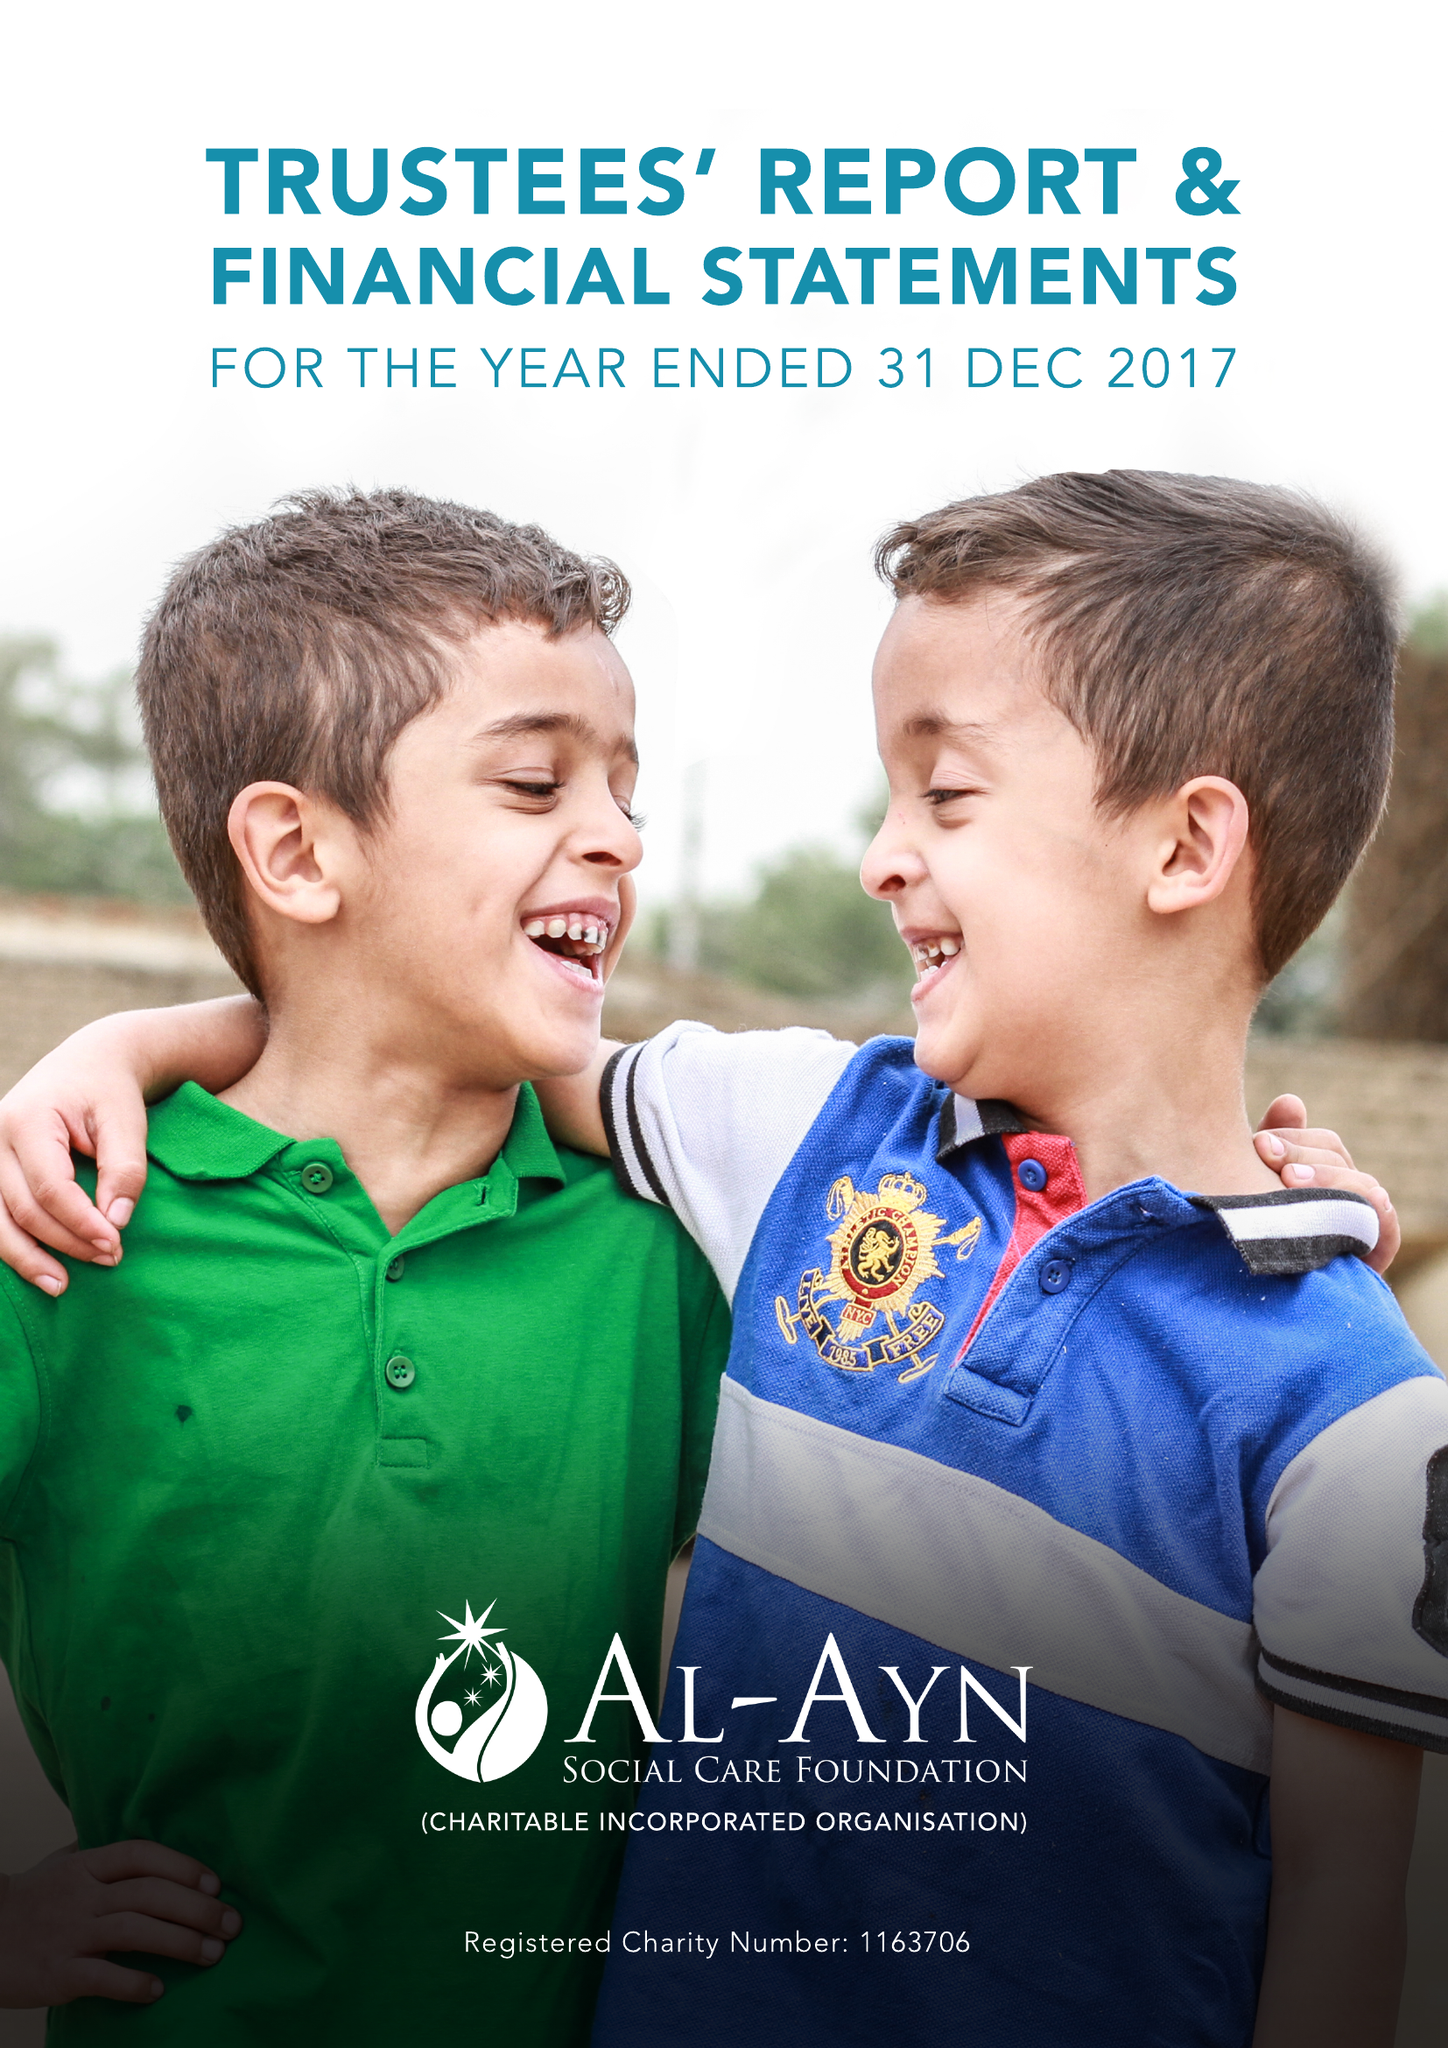What is the value for the charity_name?
Answer the question using a single word or phrase. Al-Ayn Social Care Foundation 